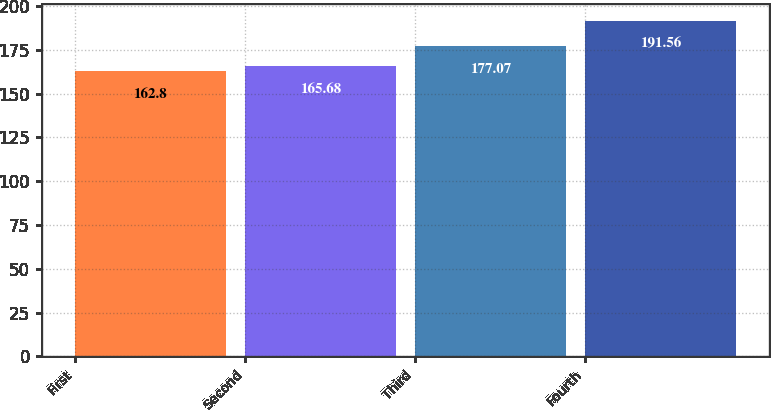Convert chart to OTSL. <chart><loc_0><loc_0><loc_500><loc_500><bar_chart><fcel>First<fcel>Second<fcel>Third<fcel>Fourth<nl><fcel>162.8<fcel>165.68<fcel>177.07<fcel>191.56<nl></chart> 